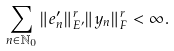Convert formula to latex. <formula><loc_0><loc_0><loc_500><loc_500>\sum _ { n \in \mathbb { N } _ { 0 } } \| e _ { n } ^ { \prime } \| ^ { r } _ { E ^ { \prime } } \| y _ { n } \| ^ { r } _ { F } < \infty .</formula> 